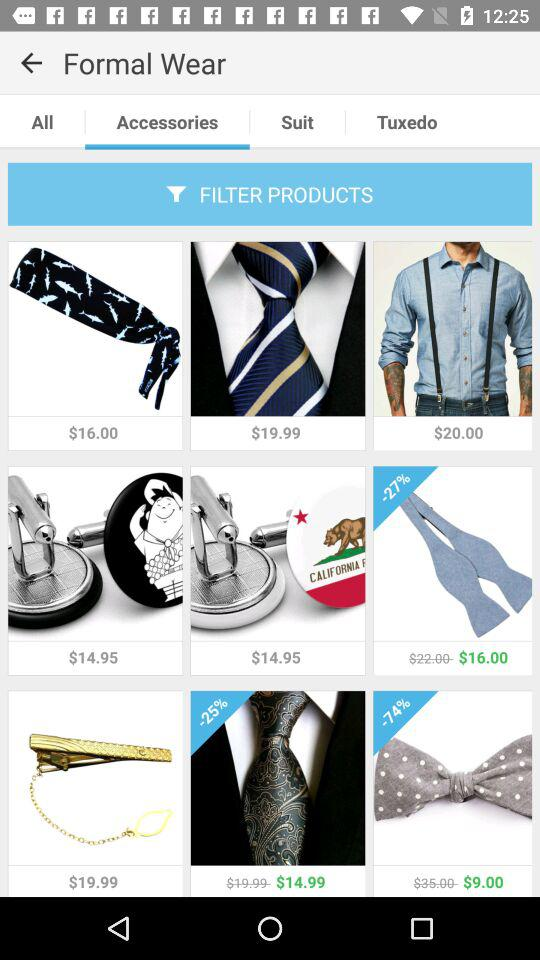How many items are on sale?
Answer the question using a single word or phrase. 3 